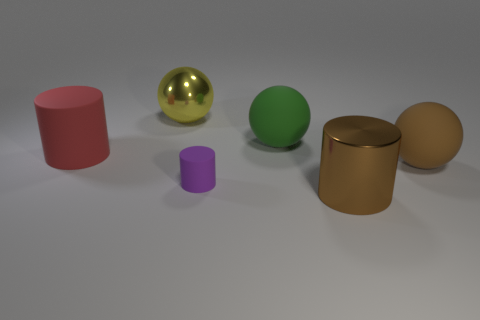Subtract all brown cylinders. How many cylinders are left? 2 Add 3 matte things. How many objects exist? 9 Subtract all gray balls. Subtract all cyan cylinders. How many balls are left? 3 Subtract 0 blue spheres. How many objects are left? 6 Subtract all gray balls. Subtract all large green objects. How many objects are left? 5 Add 3 brown cylinders. How many brown cylinders are left? 4 Add 3 purple matte things. How many purple matte things exist? 4 